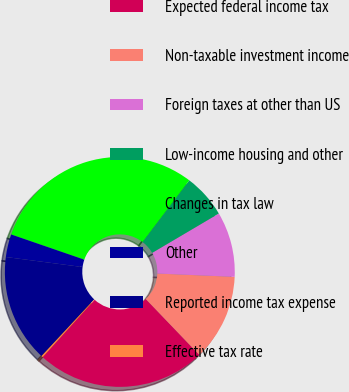Convert chart. <chart><loc_0><loc_0><loc_500><loc_500><pie_chart><fcel>Expected federal income tax<fcel>Non-taxable investment income<fcel>Foreign taxes at other than US<fcel>Low-income housing and other<fcel>Changes in tax law<fcel>Other<fcel>Reported income tax expense<fcel>Effective tax rate<nl><fcel>23.86%<fcel>12.15%<fcel>9.17%<fcel>6.19%<fcel>30.04%<fcel>3.21%<fcel>15.14%<fcel>0.23%<nl></chart> 